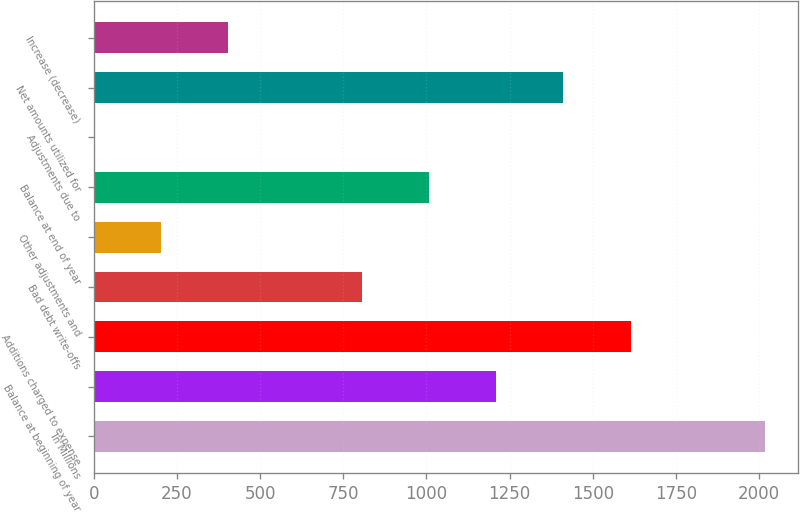Convert chart. <chart><loc_0><loc_0><loc_500><loc_500><bar_chart><fcel>In Millions<fcel>Balance at beginning of year<fcel>Additions charged to expense<fcel>Bad debt write-offs<fcel>Other adjustments and<fcel>Balance at end of year<fcel>Adjustments due to<fcel>Net amounts utilized for<fcel>Increase (decrease)<nl><fcel>2017<fcel>1210.36<fcel>1613.68<fcel>807.04<fcel>202.06<fcel>1008.7<fcel>0.4<fcel>1412.02<fcel>403.72<nl></chart> 